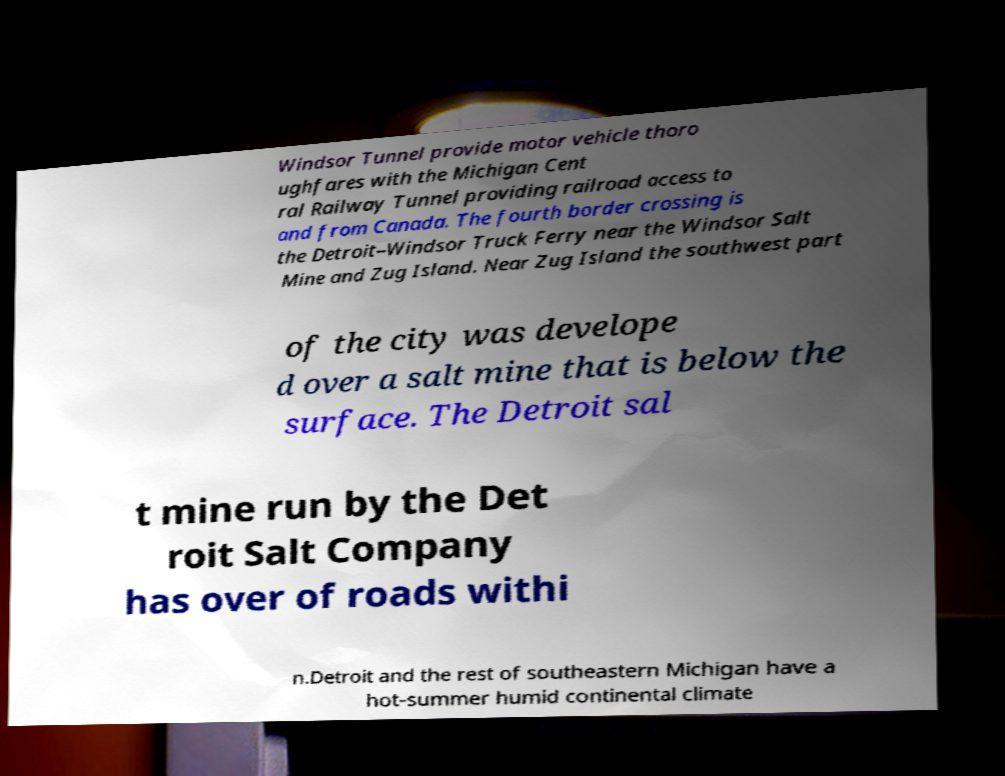What messages or text are displayed in this image? I need them in a readable, typed format. Windsor Tunnel provide motor vehicle thoro ughfares with the Michigan Cent ral Railway Tunnel providing railroad access to and from Canada. The fourth border crossing is the Detroit–Windsor Truck Ferry near the Windsor Salt Mine and Zug Island. Near Zug Island the southwest part of the city was develope d over a salt mine that is below the surface. The Detroit sal t mine run by the Det roit Salt Company has over of roads withi n.Detroit and the rest of southeastern Michigan have a hot-summer humid continental climate 